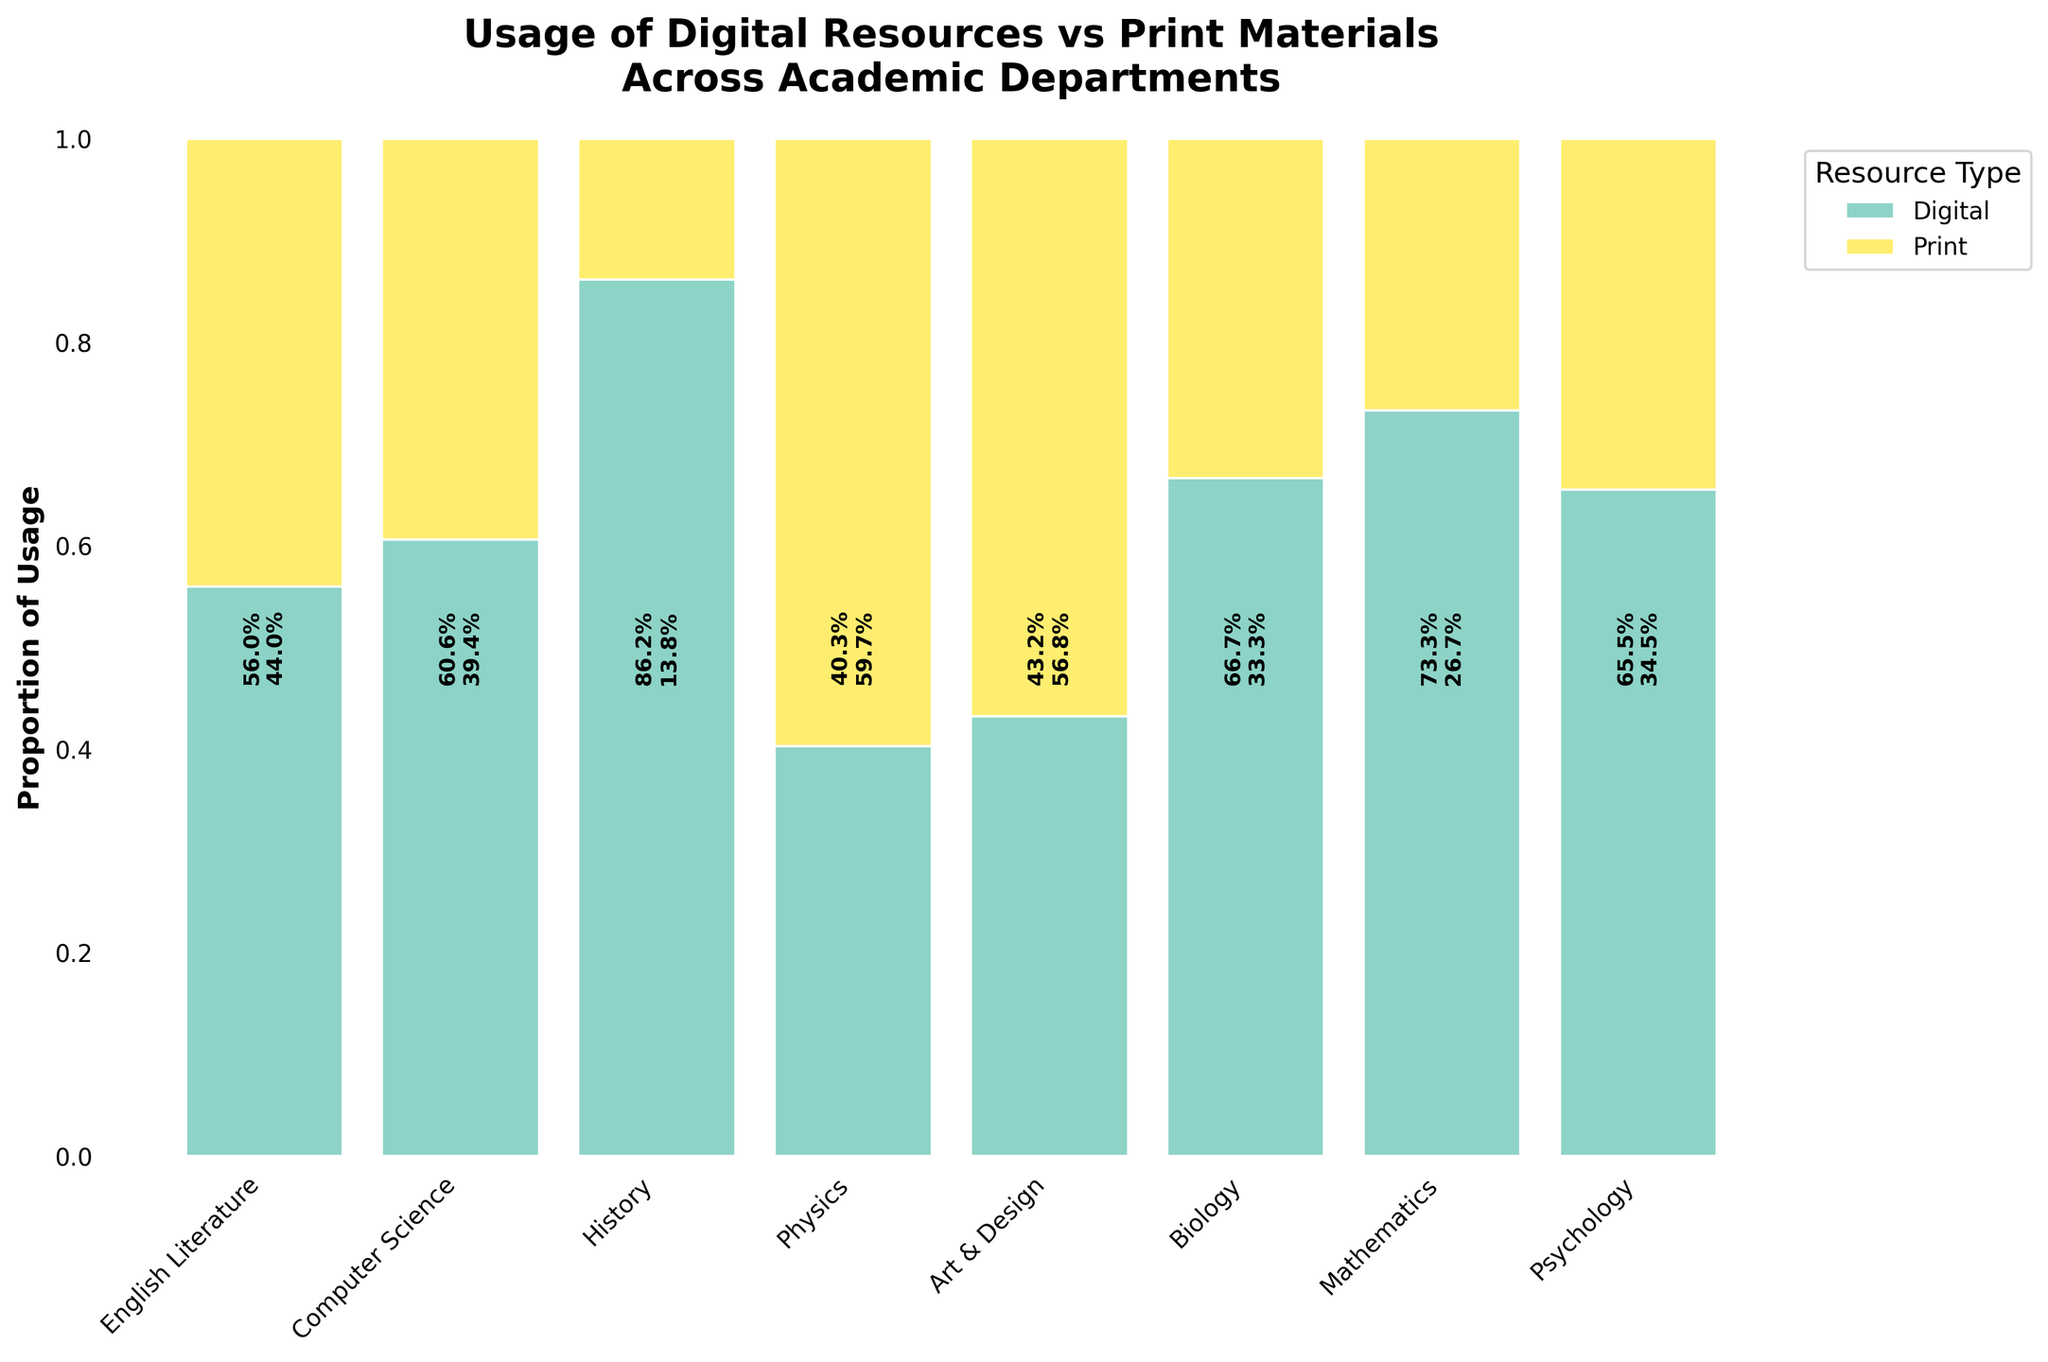Which academic department has the highest overall usage of digital resources? The heights of the digital resource bars represent the proportion of digital usage in each department. Computer Science has the highest digital bar, implying it has the most digital resource usage.
Answer: Computer Science What is the proportion of Print usage in the English Literature department? The English Literature department has digital and print usage proportions labeled. The print bar is higher, and the label on the plot should give the specific percentage.
Answer: 59.7% Which resource type is used more by the Physics department? Compare the heights of the bars for digital and print usage in the Physics department. The digital bar is higher.
Answer: Digital How does the proportion of digital resource usage in Biology compare with that in Art & Design? Look at the heights of the digital bars for Biology and Art & Design. The digital proportion for Biology is higher than Art & Design.
Answer: Higher in Biology than in Art & Design What is the total usage count for the Psychology department? Add the labeled percentages of digital and print usage in the Psychology department and use the known proportions. First, calculate total usage: 1900 (digital) + 1000 (print) = 2900.
Answer: 2900 What is the digital to print usage ratio in the Mathematics department? The proportions can be derived from the height of the bars. Digital has 1800 and Print has 900. So, 1800/900 = 2/1.
Answer: 2:1 Which department shows the most balanced usage of digital and print resources? Check the departments where digital and print bars are close to equal in height. English Literature's proportions are close to balance.
Answer: English Literature Are all departments using digital resources more than print materials? Compare the heights of each department's digital and print usage bars. Some, like History and English Literature, have higher print usage, so not all use more digital resources.
Answer: No What is the combined print resource usage of History and Physics departments? Add the print usage counts of History (2100) and Physics (800). 2100 + 800 = 2900.
Answer: 2900 